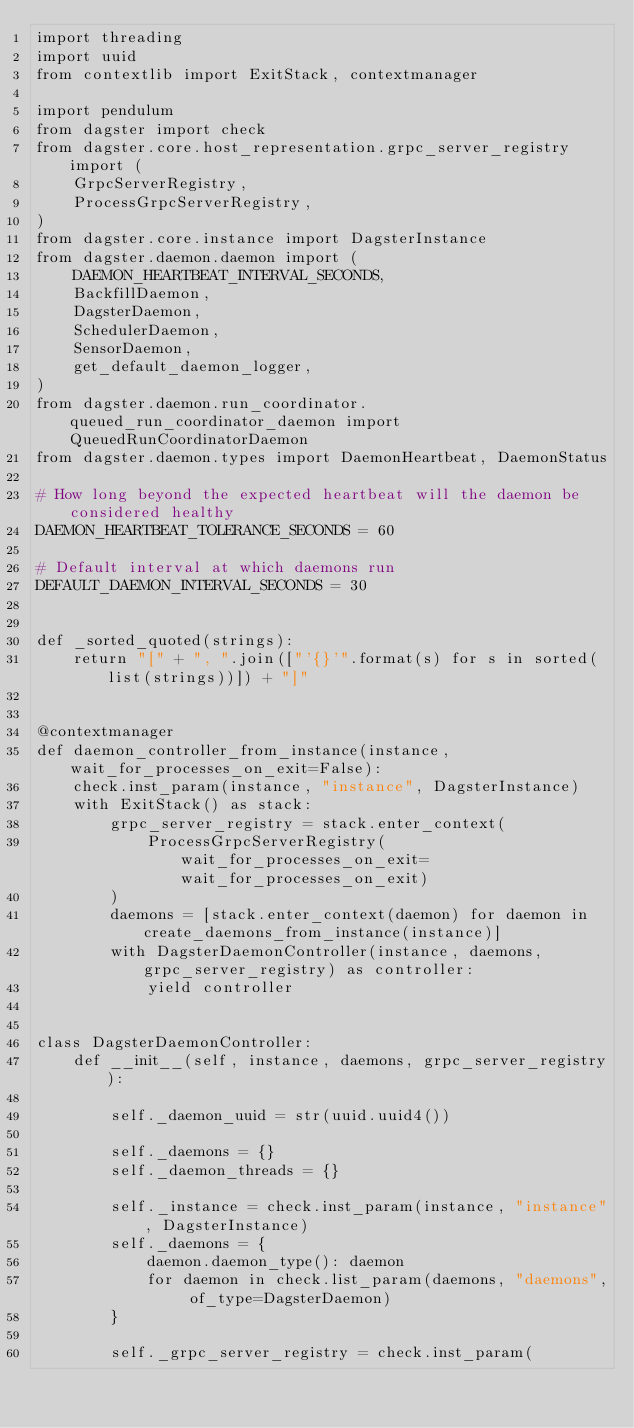<code> <loc_0><loc_0><loc_500><loc_500><_Python_>import threading
import uuid
from contextlib import ExitStack, contextmanager

import pendulum
from dagster import check
from dagster.core.host_representation.grpc_server_registry import (
    GrpcServerRegistry,
    ProcessGrpcServerRegistry,
)
from dagster.core.instance import DagsterInstance
from dagster.daemon.daemon import (
    DAEMON_HEARTBEAT_INTERVAL_SECONDS,
    BackfillDaemon,
    DagsterDaemon,
    SchedulerDaemon,
    SensorDaemon,
    get_default_daemon_logger,
)
from dagster.daemon.run_coordinator.queued_run_coordinator_daemon import QueuedRunCoordinatorDaemon
from dagster.daemon.types import DaemonHeartbeat, DaemonStatus

# How long beyond the expected heartbeat will the daemon be considered healthy
DAEMON_HEARTBEAT_TOLERANCE_SECONDS = 60

# Default interval at which daemons run
DEFAULT_DAEMON_INTERVAL_SECONDS = 30


def _sorted_quoted(strings):
    return "[" + ", ".join(["'{}'".format(s) for s in sorted(list(strings))]) + "]"


@contextmanager
def daemon_controller_from_instance(instance, wait_for_processes_on_exit=False):
    check.inst_param(instance, "instance", DagsterInstance)
    with ExitStack() as stack:
        grpc_server_registry = stack.enter_context(
            ProcessGrpcServerRegistry(wait_for_processes_on_exit=wait_for_processes_on_exit)
        )
        daemons = [stack.enter_context(daemon) for daemon in create_daemons_from_instance(instance)]
        with DagsterDaemonController(instance, daemons, grpc_server_registry) as controller:
            yield controller


class DagsterDaemonController:
    def __init__(self, instance, daemons, grpc_server_registry):

        self._daemon_uuid = str(uuid.uuid4())

        self._daemons = {}
        self._daemon_threads = {}

        self._instance = check.inst_param(instance, "instance", DagsterInstance)
        self._daemons = {
            daemon.daemon_type(): daemon
            for daemon in check.list_param(daemons, "daemons", of_type=DagsterDaemon)
        }

        self._grpc_server_registry = check.inst_param(</code> 